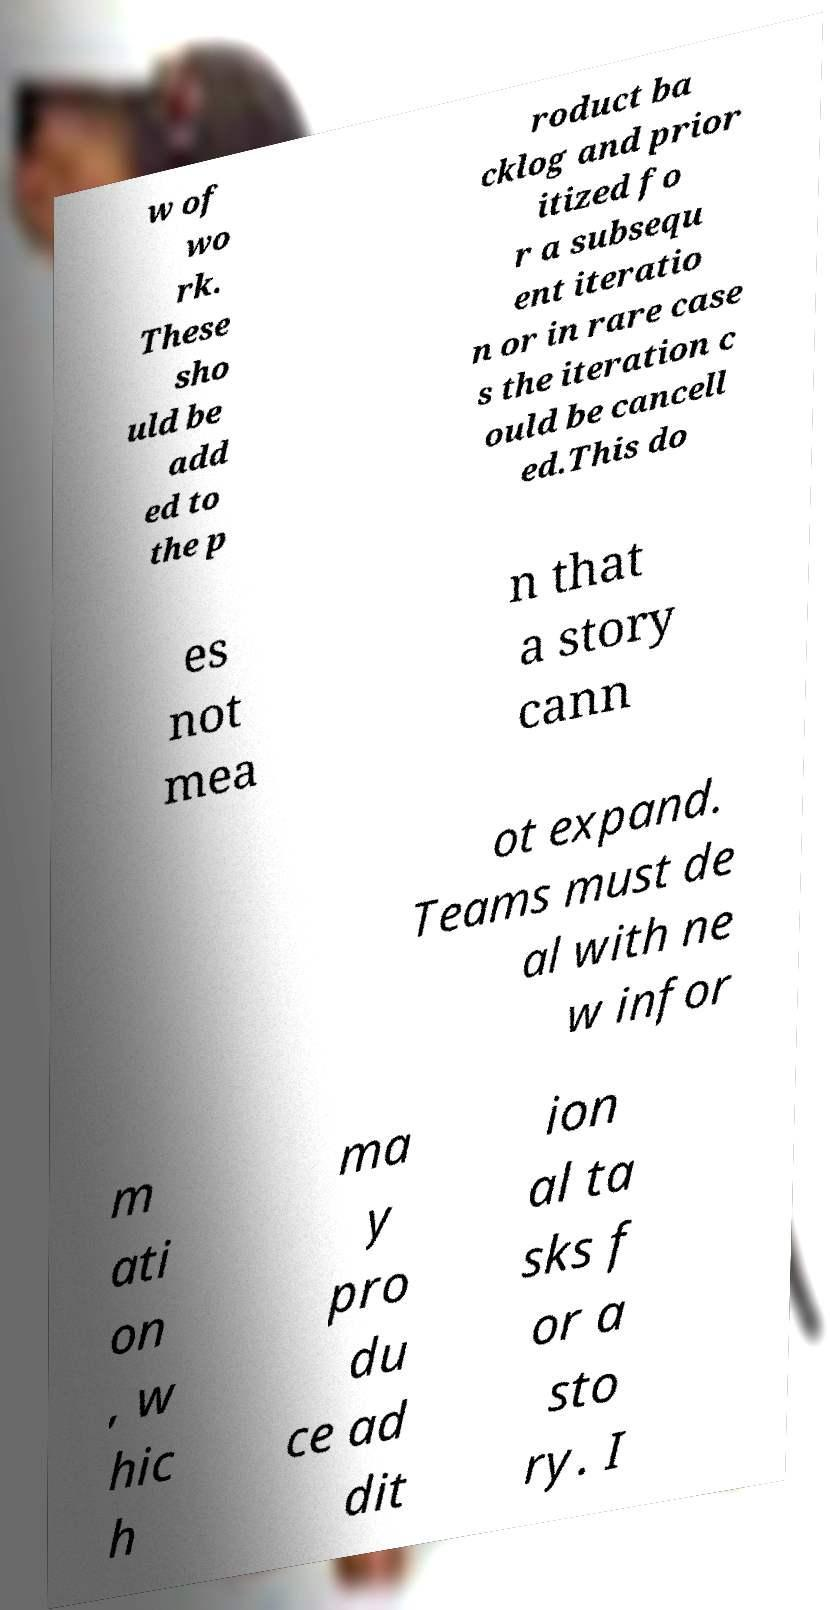I need the written content from this picture converted into text. Can you do that? w of wo rk. These sho uld be add ed to the p roduct ba cklog and prior itized fo r a subsequ ent iteratio n or in rare case s the iteration c ould be cancell ed.This do es not mea n that a story cann ot expand. Teams must de al with ne w infor m ati on , w hic h ma y pro du ce ad dit ion al ta sks f or a sto ry. I 